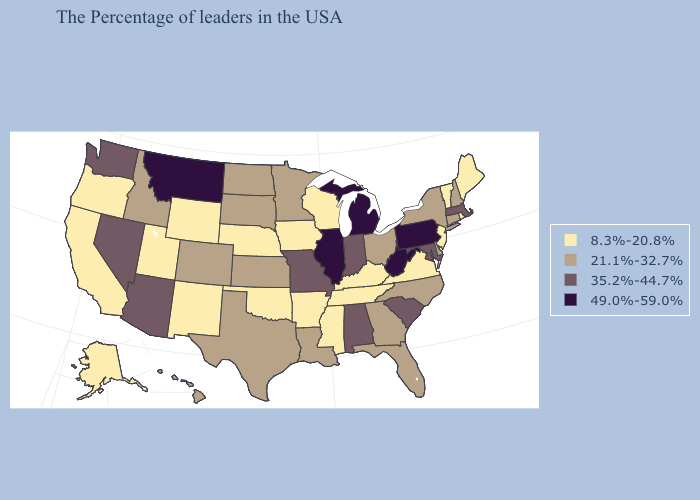Does the first symbol in the legend represent the smallest category?
Answer briefly. Yes. What is the value of Oklahoma?
Give a very brief answer. 8.3%-20.8%. Which states hav the highest value in the Northeast?
Concise answer only. Pennsylvania. Which states have the highest value in the USA?
Keep it brief. Pennsylvania, West Virginia, Michigan, Illinois, Montana. Which states have the highest value in the USA?
Quick response, please. Pennsylvania, West Virginia, Michigan, Illinois, Montana. What is the lowest value in states that border Oregon?
Concise answer only. 8.3%-20.8%. Which states have the lowest value in the MidWest?
Be succinct. Wisconsin, Iowa, Nebraska. Name the states that have a value in the range 8.3%-20.8%?
Keep it brief. Maine, Rhode Island, Vermont, New Jersey, Virginia, Kentucky, Tennessee, Wisconsin, Mississippi, Arkansas, Iowa, Nebraska, Oklahoma, Wyoming, New Mexico, Utah, California, Oregon, Alaska. Which states hav the highest value in the Northeast?
Keep it brief. Pennsylvania. How many symbols are there in the legend?
Quick response, please. 4. Is the legend a continuous bar?
Give a very brief answer. No. Which states have the lowest value in the USA?
Short answer required. Maine, Rhode Island, Vermont, New Jersey, Virginia, Kentucky, Tennessee, Wisconsin, Mississippi, Arkansas, Iowa, Nebraska, Oklahoma, Wyoming, New Mexico, Utah, California, Oregon, Alaska. Which states have the lowest value in the West?
Quick response, please. Wyoming, New Mexico, Utah, California, Oregon, Alaska. Name the states that have a value in the range 21.1%-32.7%?
Keep it brief. New Hampshire, Connecticut, New York, Delaware, North Carolina, Ohio, Florida, Georgia, Louisiana, Minnesota, Kansas, Texas, South Dakota, North Dakota, Colorado, Idaho, Hawaii. 